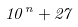<formula> <loc_0><loc_0><loc_500><loc_500>1 0 ^ { n } + 2 7</formula> 